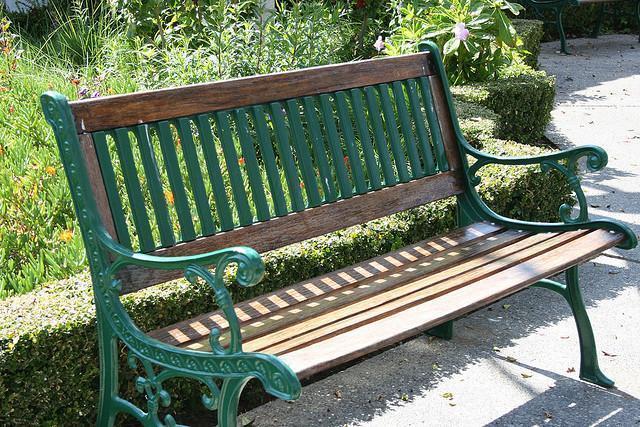How many benches can be seen?
Give a very brief answer. 1. How many boys take the pizza in the image?
Give a very brief answer. 0. 